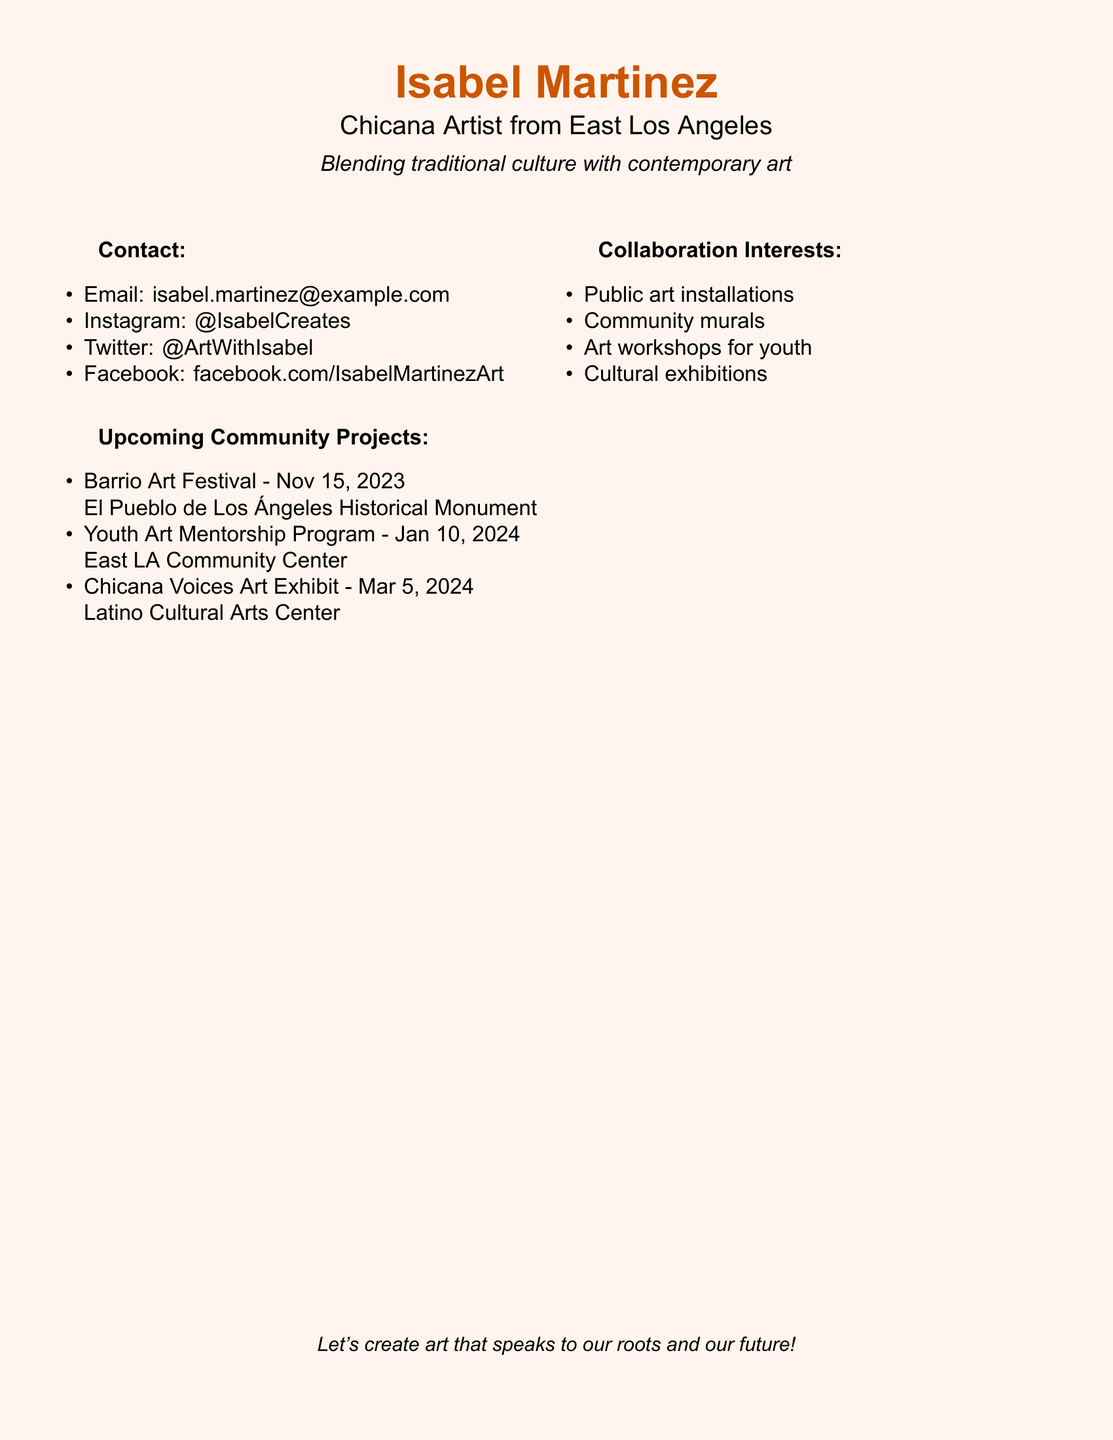What is the name of the artist? The name of the artist is prominently displayed at the top of the card.
Answer: Isabel Martinez What city is the artist from? The artist's location is mentioned under their name.
Answer: East Los Angeles What type of art does Isabel specialize in? The artist describes their focus on blending traditional culture with a modern approach.
Answer: Traditional culture with contemporary art When is the Barrio Art Festival scheduled? The date for the event is listed under Upcoming Community Projects.
Answer: Nov 15, 2023 What workshop does Isabel offer for youth? The document mentions specific types of collaborative interests, including workshops.
Answer: Art workshops for youth Which platform features Isabel's artistic work? The document includes multiple social media accounts to connect with the artist.
Answer: Instagram, Twitter, Facebook Where will the Chicana Voices Art Exhibit take place? The location of the exhibit is specified in the document.
Answer: Latino Cultural Arts Center How many upcoming community projects are listed? The document enumerates specific projects under the respective heading.
Answer: Three What is the purpose of Isabel's community projects? The projects are geared towards artistic collaboration and community engagement.
Answer: To create art that speaks to our roots and our future! 